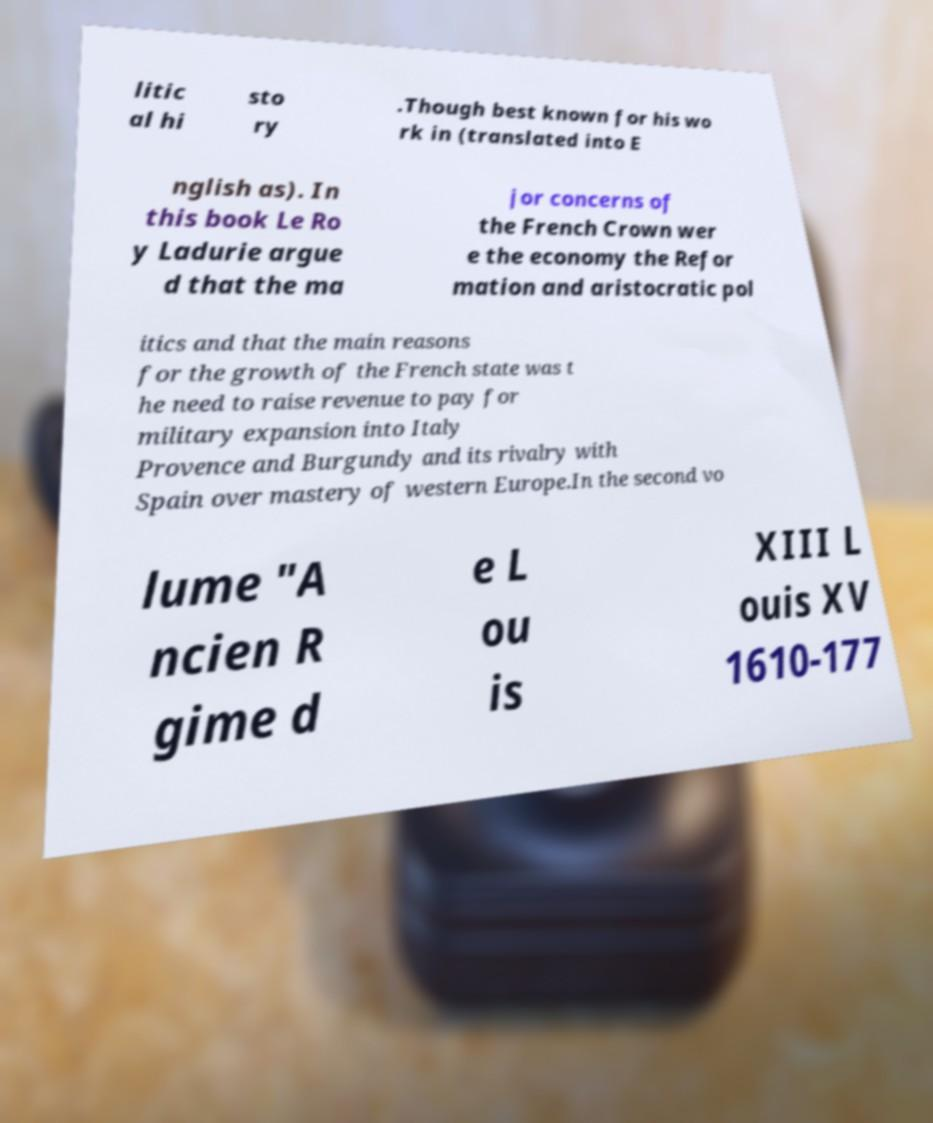Could you extract and type out the text from this image? litic al hi sto ry .Though best known for his wo rk in (translated into E nglish as). In this book Le Ro y Ladurie argue d that the ma jor concerns of the French Crown wer e the economy the Refor mation and aristocratic pol itics and that the main reasons for the growth of the French state was t he need to raise revenue to pay for military expansion into Italy Provence and Burgundy and its rivalry with Spain over mastery of western Europe.In the second vo lume "A ncien R gime d e L ou is XIII L ouis XV 1610-177 